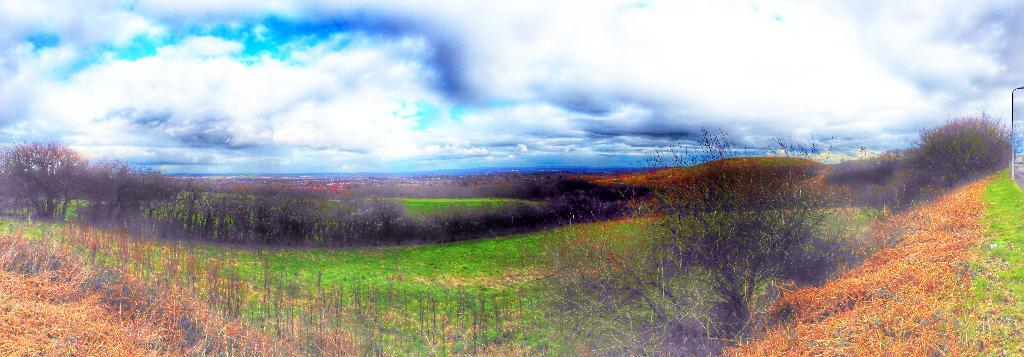What can be found at the bottom of the image? There are plants, grass, and trees at the bottom of the image. What type of terrain is visible at the top of the image? There are hills at the top of the image. What is visible in the farthest away in the image? The sky is visible at the top of the image, with clouds present. Is there a mailbox visible in the image? There is no mailbox present in the image. Can you tell me how many wishes are granted in the image? There is no mention of wishes or any related activity in the image. 